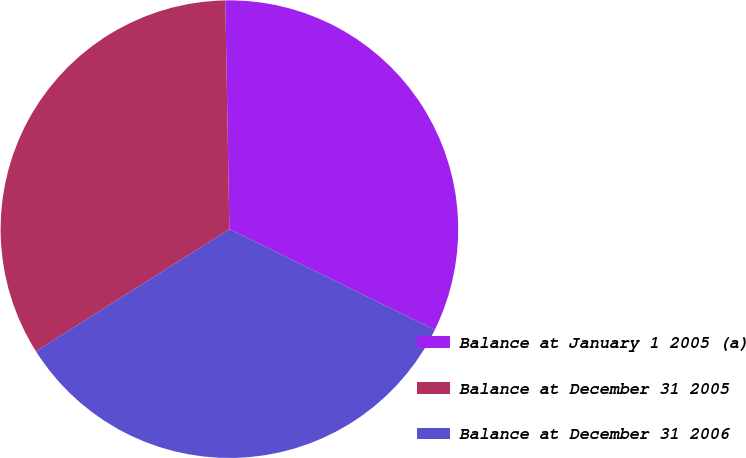<chart> <loc_0><loc_0><loc_500><loc_500><pie_chart><fcel>Balance at January 1 2005 (a)<fcel>Balance at December 31 2005<fcel>Balance at December 31 2006<nl><fcel>32.53%<fcel>33.68%<fcel>33.79%<nl></chart> 